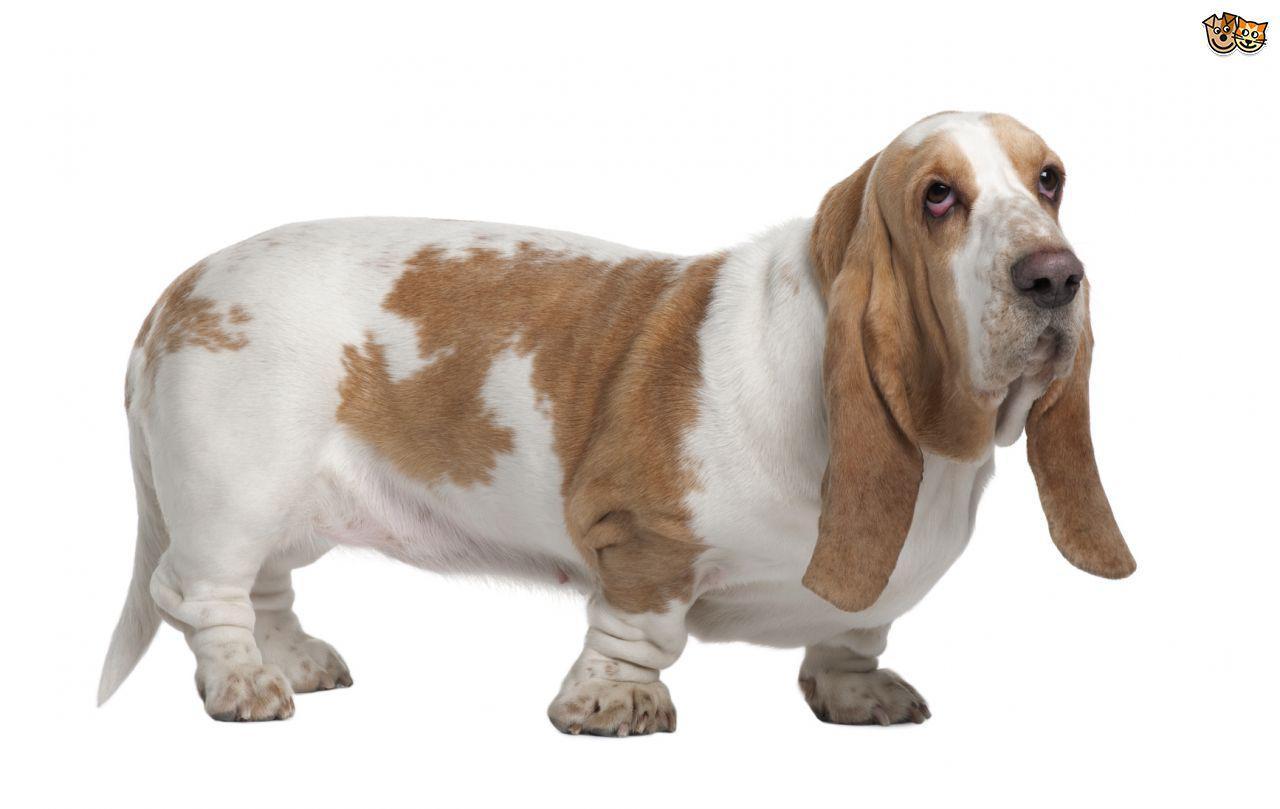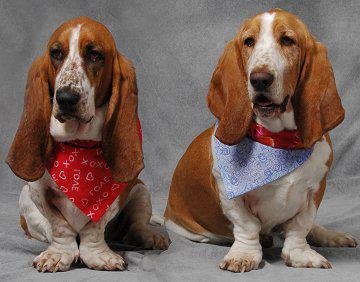The first image is the image on the left, the second image is the image on the right. Evaluate the accuracy of this statement regarding the images: "There are two dogs total on both images.". Is it true? Answer yes or no. No. 